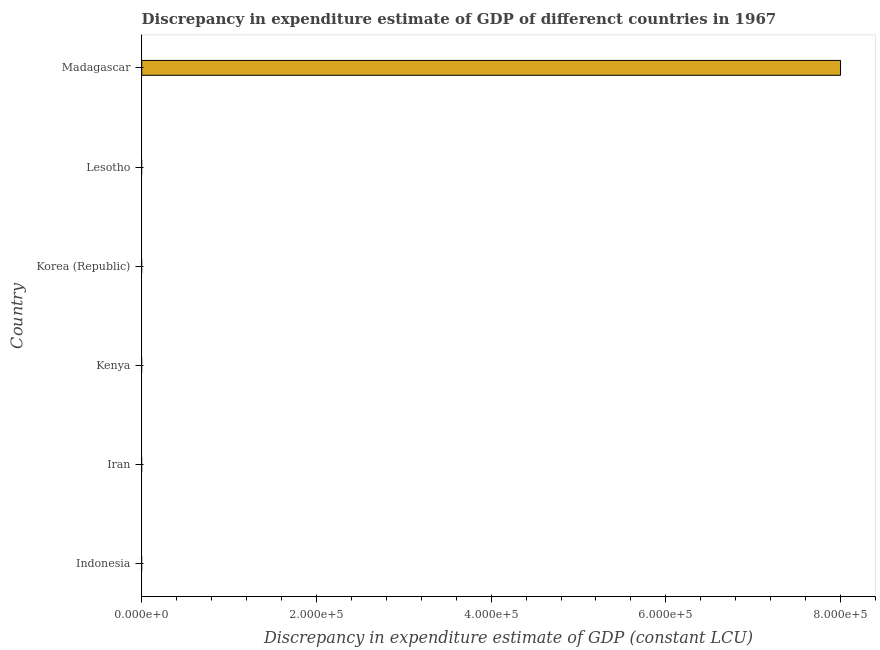What is the title of the graph?
Your answer should be compact. Discrepancy in expenditure estimate of GDP of differenct countries in 1967. What is the label or title of the X-axis?
Your answer should be compact. Discrepancy in expenditure estimate of GDP (constant LCU). In which country was the discrepancy in expenditure estimate of gdp maximum?
Your answer should be compact. Madagascar. What is the sum of the discrepancy in expenditure estimate of gdp?
Offer a terse response. 8.00e+05. What is the average discrepancy in expenditure estimate of gdp per country?
Your response must be concise. 1.33e+05. What is the difference between the highest and the lowest discrepancy in expenditure estimate of gdp?
Keep it short and to the point. 8.00e+05. In how many countries, is the discrepancy in expenditure estimate of gdp greater than the average discrepancy in expenditure estimate of gdp taken over all countries?
Keep it short and to the point. 1. How many bars are there?
Offer a very short reply. 1. Are all the bars in the graph horizontal?
Offer a very short reply. Yes. What is the Discrepancy in expenditure estimate of GDP (constant LCU) in Korea (Republic)?
Ensure brevity in your answer.  0. What is the Discrepancy in expenditure estimate of GDP (constant LCU) in Lesotho?
Your answer should be compact. 0. What is the Discrepancy in expenditure estimate of GDP (constant LCU) of Madagascar?
Keep it short and to the point. 8.00e+05. 